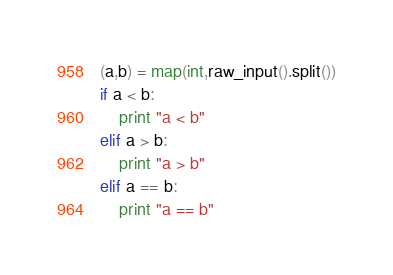Convert code to text. <code><loc_0><loc_0><loc_500><loc_500><_Python_>(a,b) = map(int,raw_input().split())
if a < b:
	print "a < b"
elif a > b:
	print "a > b"
elif a == b:
	print "a == b"</code> 